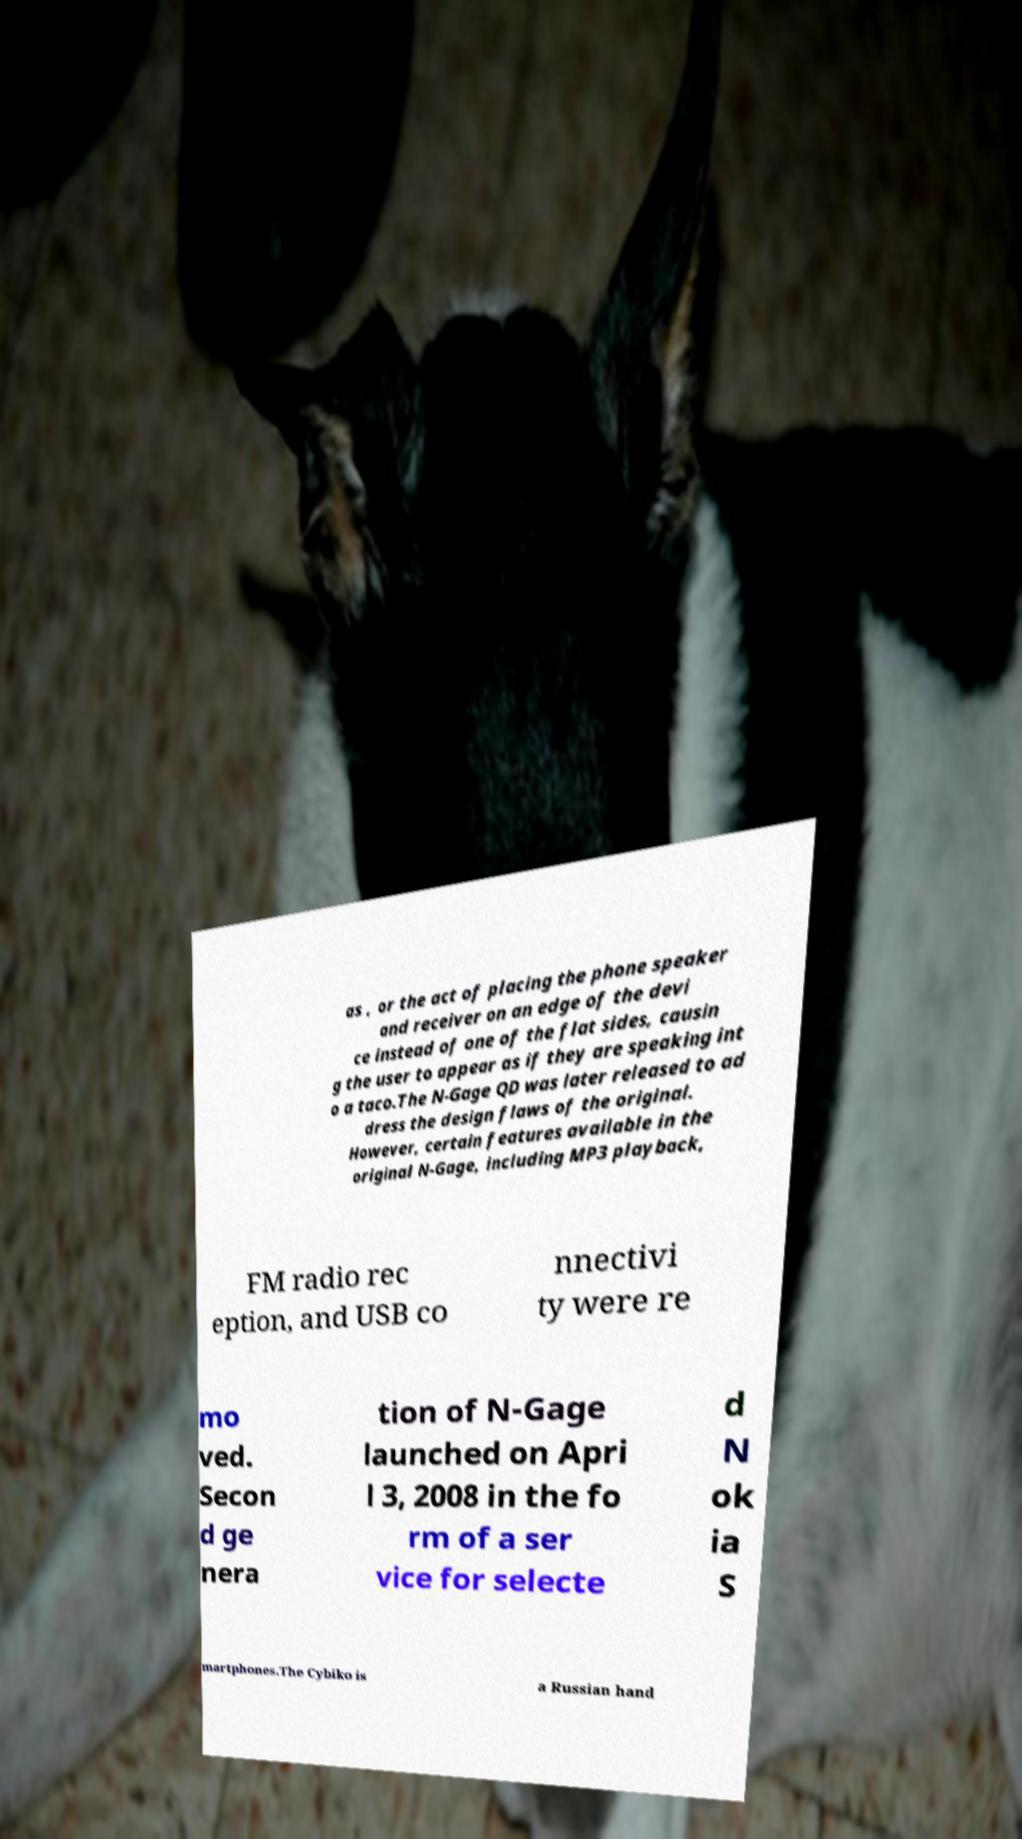Please read and relay the text visible in this image. What does it say? as , or the act of placing the phone speaker and receiver on an edge of the devi ce instead of one of the flat sides, causin g the user to appear as if they are speaking int o a taco.The N-Gage QD was later released to ad dress the design flaws of the original. However, certain features available in the original N-Gage, including MP3 playback, FM radio rec eption, and USB co nnectivi ty were re mo ved. Secon d ge nera tion of N-Gage launched on Apri l 3, 2008 in the fo rm of a ser vice for selecte d N ok ia S martphones.The Cybiko is a Russian hand 